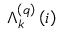<formula> <loc_0><loc_0><loc_500><loc_500>\Lambda _ { k } ^ { \left ( q \right ) } \left ( i \right )</formula> 